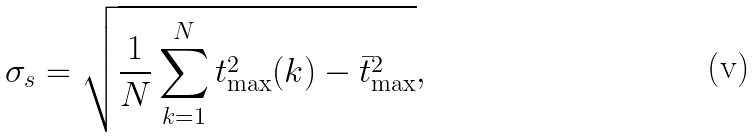<formula> <loc_0><loc_0><loc_500><loc_500>\sigma _ { s } = \sqrt { \frac { 1 } { N } \sum _ { k = 1 } ^ { N } t _ { \max } ^ { 2 } ( k ) - \bar { t } _ { \max } ^ { 2 } } ,</formula> 